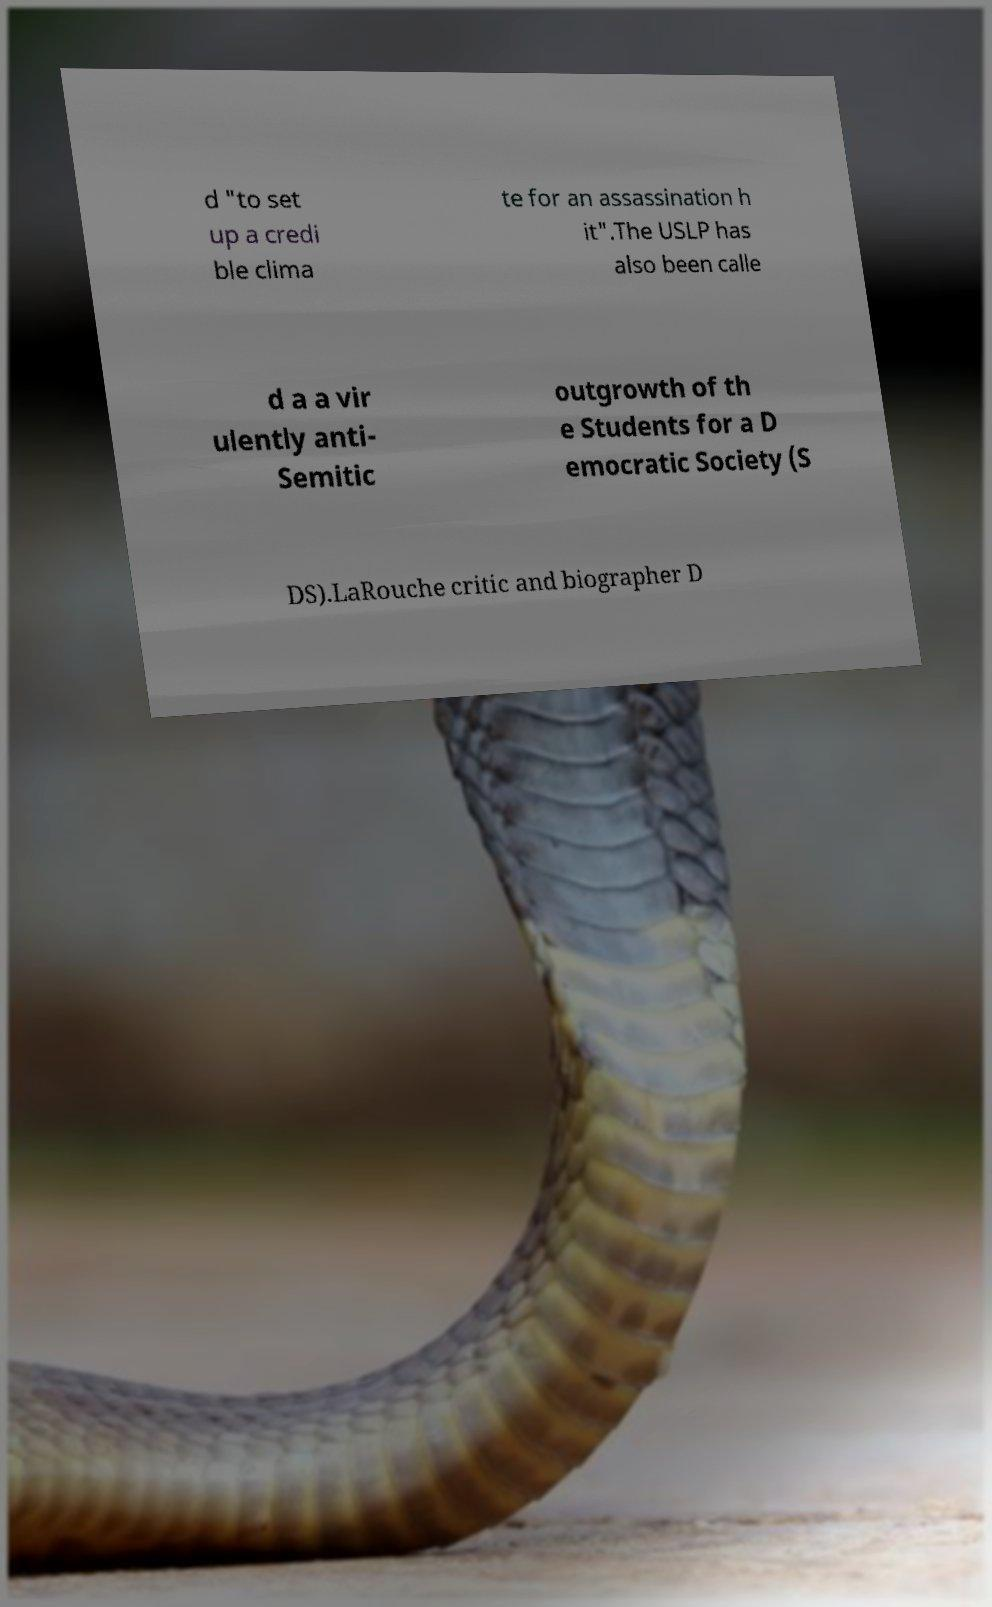Please read and relay the text visible in this image. What does it say? d "to set up a credi ble clima te for an assassination h it".The USLP has also been calle d a a vir ulently anti- Semitic outgrowth of th e Students for a D emocratic Society (S DS).LaRouche critic and biographer D 